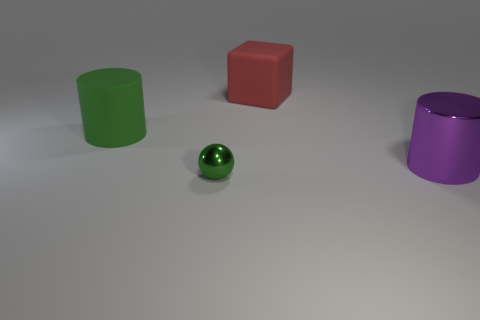Subtract 1 cylinders. How many cylinders are left? 1 Add 2 green metal spheres. How many objects exist? 6 Subtract all blue cylinders. Subtract all gray cubes. How many cylinders are left? 2 Subtract all blue blocks. How many purple cylinders are left? 1 Subtract all rubber cylinders. Subtract all tiny green objects. How many objects are left? 2 Add 1 red cubes. How many red cubes are left? 2 Add 2 tiny blue matte cylinders. How many tiny blue matte cylinders exist? 2 Subtract 0 gray cylinders. How many objects are left? 4 